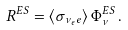<formula> <loc_0><loc_0><loc_500><loc_500>R ^ { E S } = \langle \sigma _ { \nu _ { e } e } \rangle \, \Phi _ { \nu } ^ { E S } \, .</formula> 